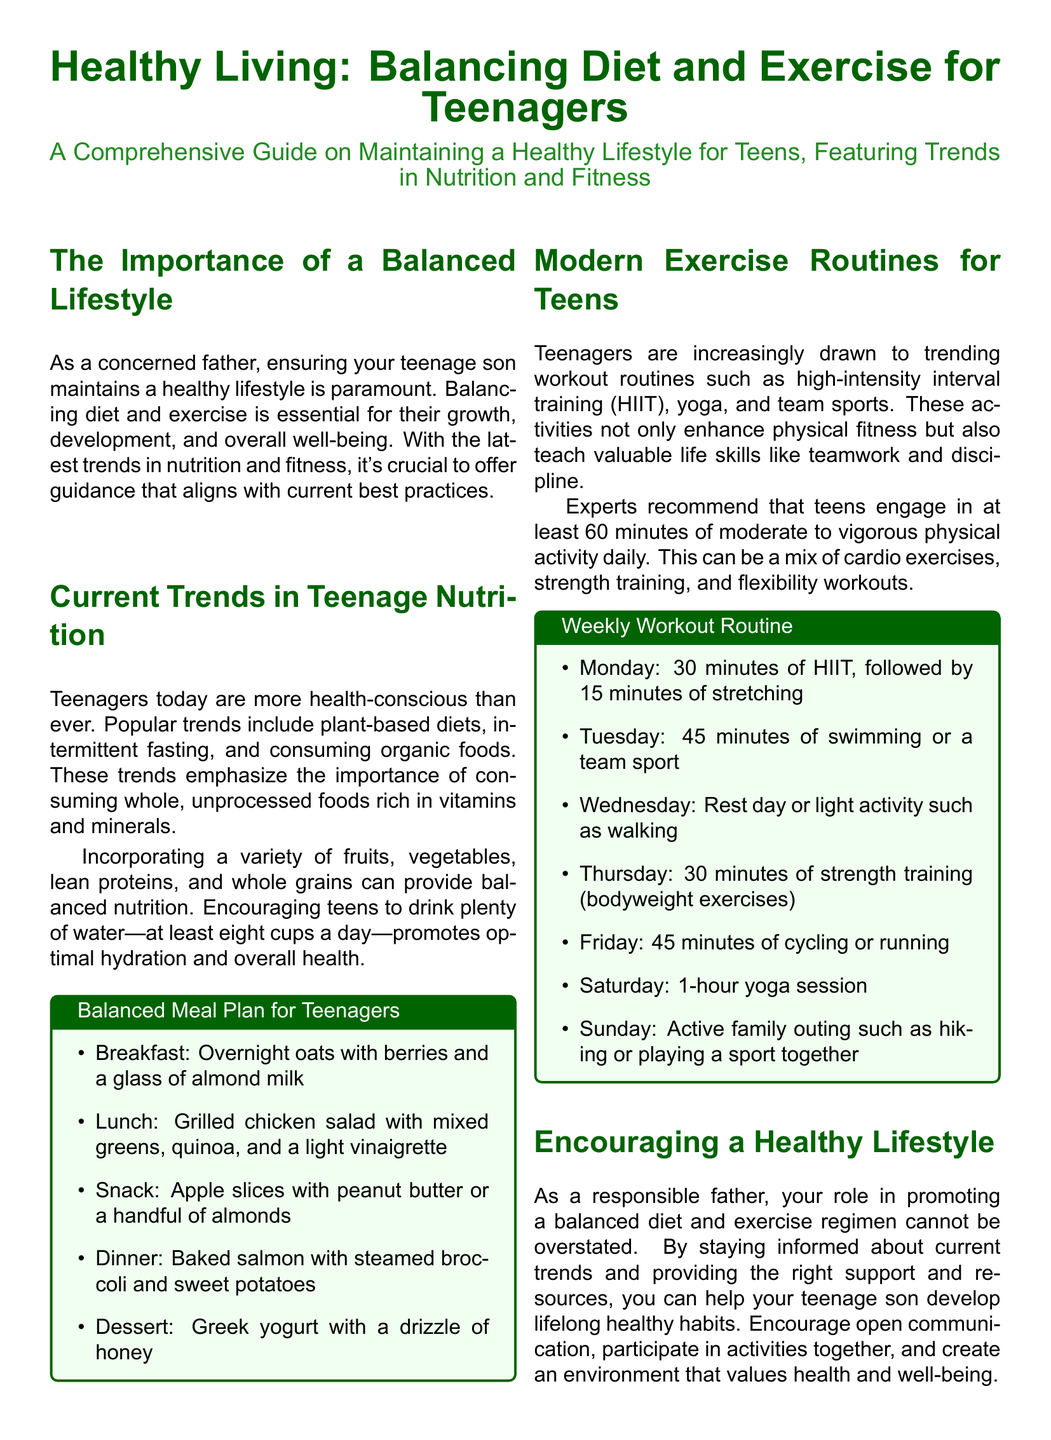What is the primary focus of the article? The article emphasizes the importance of maintaining a healthy lifestyle through diet and exercise for teenagers.
Answer: Healthy lifestyle How many cups of water should teenagers drink daily? The document states that teenagers should drink at least eight cups of water a day.
Answer: Eight cups What type of meal is suggested for breakfast? The balanced meal plan for breakfast includes overnight oats with berries and a glass of almond milk.
Answer: Overnight oats What is a recommended activity for Wednesday in the workout routine? The recommended activity for Wednesday is a rest day or light activity such as walking.
Answer: Rest day How many minutes of physical activity are recommended for teens daily? The document recommends at least 60 minutes of moderate to vigorous physical activity daily for teenagers.
Answer: Sixty minutes What trend in nutrition emphasizes whole, unprocessed foods? The article mentions that popular nutrition trends include plant-based diets and organic foods, focusing on whole, unprocessed foods.
Answer: Plant-based diets What is one recommended dinner option in the meal plan? The balanced meal plan suggests baked salmon with steamed broccoli and sweet potatoes for dinner.
Answer: Baked salmon Which exercise routine is included in the weekly workout suggestions? The document includes high-intensity interval training (HIIT) as a trending workout routine for teens.
Answer: HIIT What role does a father play in promoting a healthy lifestyle for their teenage son? The article emphasizes the father's responsibility in promoting a balanced diet and exercise regimen.
Answer: Promoting a balanced diet 